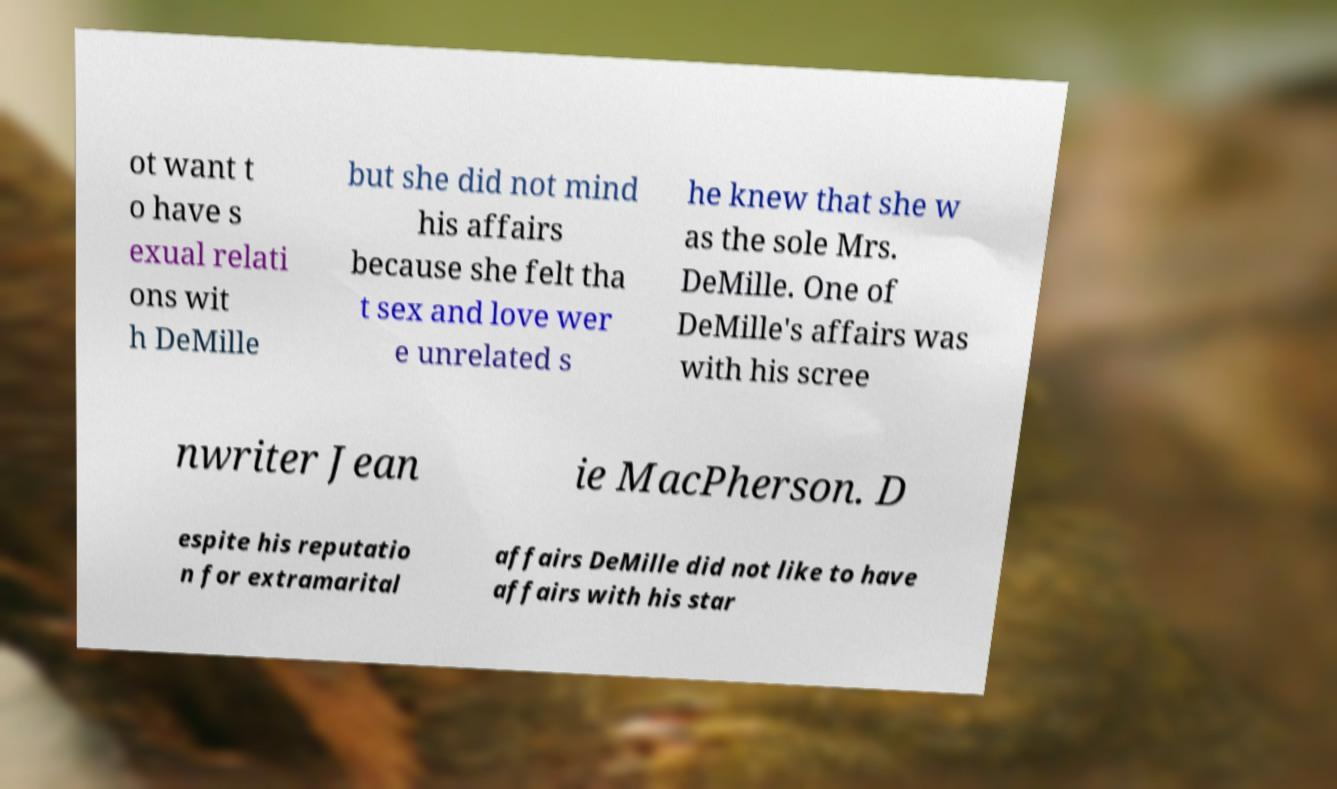Please identify and transcribe the text found in this image. ot want t o have s exual relati ons wit h DeMille but she did not mind his affairs because she felt tha t sex and love wer e unrelated s he knew that she w as the sole Mrs. DeMille. One of DeMille's affairs was with his scree nwriter Jean ie MacPherson. D espite his reputatio n for extramarital affairs DeMille did not like to have affairs with his star 